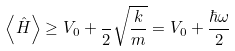Convert formula to latex. <formula><loc_0><loc_0><loc_500><loc_500>\left \langle { \hat { H } } \right \rangle \geq V _ { 0 } + { \frac { } { 2 } } { \sqrt { \frac { k } { m } } } = V _ { 0 } + { \frac { \hbar { \omega } } { 2 } }</formula> 